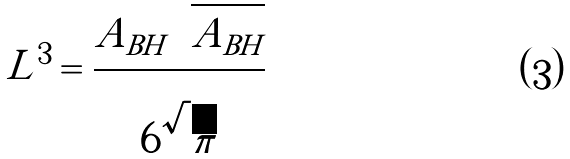<formula> <loc_0><loc_0><loc_500><loc_500>L ^ { 3 } = \frac { A _ { B H } \sqrt { A _ { B H } } } { 6 \sqrt { \pi } }</formula> 